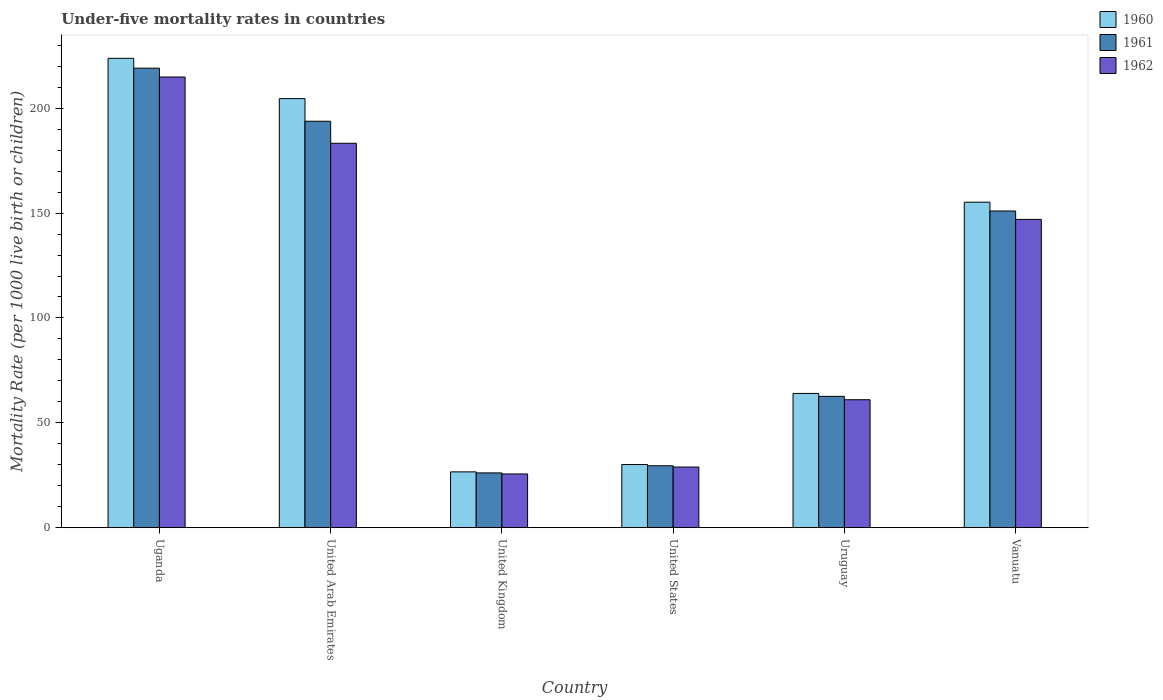How many different coloured bars are there?
Offer a very short reply. 3. How many groups of bars are there?
Your answer should be very brief. 6. Are the number of bars per tick equal to the number of legend labels?
Offer a very short reply. Yes. What is the label of the 6th group of bars from the left?
Provide a succinct answer. Vanuatu. In how many cases, is the number of bars for a given country not equal to the number of legend labels?
Provide a succinct answer. 0. What is the under-five mortality rate in 1962 in Uganda?
Keep it short and to the point. 214.9. Across all countries, what is the maximum under-five mortality rate in 1962?
Your answer should be very brief. 214.9. Across all countries, what is the minimum under-five mortality rate in 1961?
Keep it short and to the point. 26.1. In which country was the under-five mortality rate in 1960 maximum?
Your answer should be very brief. Uganda. What is the total under-five mortality rate in 1961 in the graph?
Provide a short and direct response. 682.1. What is the difference between the under-five mortality rate in 1962 in Uganda and that in United States?
Give a very brief answer. 186. What is the average under-five mortality rate in 1960 per country?
Offer a terse response. 117.38. What is the difference between the under-five mortality rate of/in 1960 and under-five mortality rate of/in 1961 in Uruguay?
Your response must be concise. 1.4. What is the ratio of the under-five mortality rate in 1962 in United Arab Emirates to that in Vanuatu?
Your response must be concise. 1.25. Is the under-five mortality rate in 1960 in United Kingdom less than that in Uruguay?
Provide a short and direct response. Yes. Is the difference between the under-five mortality rate in 1960 in United Arab Emirates and United States greater than the difference between the under-five mortality rate in 1961 in United Arab Emirates and United States?
Ensure brevity in your answer.  Yes. What is the difference between the highest and the second highest under-five mortality rate in 1960?
Offer a terse response. -49.4. What is the difference between the highest and the lowest under-five mortality rate in 1962?
Give a very brief answer. 189.3. What does the 2nd bar from the right in Uruguay represents?
Keep it short and to the point. 1961. Is it the case that in every country, the sum of the under-five mortality rate in 1962 and under-five mortality rate in 1960 is greater than the under-five mortality rate in 1961?
Your answer should be compact. Yes. How many countries are there in the graph?
Provide a succinct answer. 6. Does the graph contain any zero values?
Ensure brevity in your answer.  No. What is the title of the graph?
Offer a terse response. Under-five mortality rates in countries. What is the label or title of the Y-axis?
Offer a very short reply. Mortality Rate (per 1000 live birth or children). What is the Mortality Rate (per 1000 live birth or children) of 1960 in Uganda?
Your answer should be compact. 223.8. What is the Mortality Rate (per 1000 live birth or children) in 1961 in Uganda?
Your response must be concise. 219.1. What is the Mortality Rate (per 1000 live birth or children) in 1962 in Uganda?
Offer a terse response. 214.9. What is the Mortality Rate (per 1000 live birth or children) in 1960 in United Arab Emirates?
Your answer should be very brief. 204.6. What is the Mortality Rate (per 1000 live birth or children) of 1961 in United Arab Emirates?
Offer a terse response. 193.8. What is the Mortality Rate (per 1000 live birth or children) in 1962 in United Arab Emirates?
Provide a succinct answer. 183.3. What is the Mortality Rate (per 1000 live birth or children) in 1960 in United Kingdom?
Your answer should be very brief. 26.6. What is the Mortality Rate (per 1000 live birth or children) in 1961 in United Kingdom?
Your response must be concise. 26.1. What is the Mortality Rate (per 1000 live birth or children) in 1962 in United Kingdom?
Your answer should be very brief. 25.6. What is the Mortality Rate (per 1000 live birth or children) in 1960 in United States?
Give a very brief answer. 30.1. What is the Mortality Rate (per 1000 live birth or children) of 1961 in United States?
Offer a terse response. 29.5. What is the Mortality Rate (per 1000 live birth or children) in 1962 in United States?
Make the answer very short. 28.9. What is the Mortality Rate (per 1000 live birth or children) of 1961 in Uruguay?
Give a very brief answer. 62.6. What is the Mortality Rate (per 1000 live birth or children) in 1962 in Uruguay?
Provide a short and direct response. 61. What is the Mortality Rate (per 1000 live birth or children) in 1960 in Vanuatu?
Give a very brief answer. 155.2. What is the Mortality Rate (per 1000 live birth or children) of 1961 in Vanuatu?
Make the answer very short. 151. What is the Mortality Rate (per 1000 live birth or children) of 1962 in Vanuatu?
Your answer should be very brief. 147. Across all countries, what is the maximum Mortality Rate (per 1000 live birth or children) of 1960?
Provide a short and direct response. 223.8. Across all countries, what is the maximum Mortality Rate (per 1000 live birth or children) of 1961?
Make the answer very short. 219.1. Across all countries, what is the maximum Mortality Rate (per 1000 live birth or children) in 1962?
Your answer should be very brief. 214.9. Across all countries, what is the minimum Mortality Rate (per 1000 live birth or children) in 1960?
Your answer should be compact. 26.6. Across all countries, what is the minimum Mortality Rate (per 1000 live birth or children) of 1961?
Your answer should be very brief. 26.1. Across all countries, what is the minimum Mortality Rate (per 1000 live birth or children) of 1962?
Offer a terse response. 25.6. What is the total Mortality Rate (per 1000 live birth or children) of 1960 in the graph?
Offer a very short reply. 704.3. What is the total Mortality Rate (per 1000 live birth or children) of 1961 in the graph?
Give a very brief answer. 682.1. What is the total Mortality Rate (per 1000 live birth or children) of 1962 in the graph?
Your response must be concise. 660.7. What is the difference between the Mortality Rate (per 1000 live birth or children) in 1961 in Uganda and that in United Arab Emirates?
Offer a very short reply. 25.3. What is the difference between the Mortality Rate (per 1000 live birth or children) in 1962 in Uganda and that in United Arab Emirates?
Offer a very short reply. 31.6. What is the difference between the Mortality Rate (per 1000 live birth or children) of 1960 in Uganda and that in United Kingdom?
Provide a short and direct response. 197.2. What is the difference between the Mortality Rate (per 1000 live birth or children) of 1961 in Uganda and that in United Kingdom?
Ensure brevity in your answer.  193. What is the difference between the Mortality Rate (per 1000 live birth or children) in 1962 in Uganda and that in United Kingdom?
Your answer should be compact. 189.3. What is the difference between the Mortality Rate (per 1000 live birth or children) of 1960 in Uganda and that in United States?
Ensure brevity in your answer.  193.7. What is the difference between the Mortality Rate (per 1000 live birth or children) of 1961 in Uganda and that in United States?
Provide a short and direct response. 189.6. What is the difference between the Mortality Rate (per 1000 live birth or children) in 1962 in Uganda and that in United States?
Offer a terse response. 186. What is the difference between the Mortality Rate (per 1000 live birth or children) in 1960 in Uganda and that in Uruguay?
Your answer should be compact. 159.8. What is the difference between the Mortality Rate (per 1000 live birth or children) of 1961 in Uganda and that in Uruguay?
Give a very brief answer. 156.5. What is the difference between the Mortality Rate (per 1000 live birth or children) in 1962 in Uganda and that in Uruguay?
Your answer should be compact. 153.9. What is the difference between the Mortality Rate (per 1000 live birth or children) of 1960 in Uganda and that in Vanuatu?
Give a very brief answer. 68.6. What is the difference between the Mortality Rate (per 1000 live birth or children) of 1961 in Uganda and that in Vanuatu?
Your answer should be very brief. 68.1. What is the difference between the Mortality Rate (per 1000 live birth or children) in 1962 in Uganda and that in Vanuatu?
Your answer should be very brief. 67.9. What is the difference between the Mortality Rate (per 1000 live birth or children) of 1960 in United Arab Emirates and that in United Kingdom?
Offer a terse response. 178. What is the difference between the Mortality Rate (per 1000 live birth or children) of 1961 in United Arab Emirates and that in United Kingdom?
Offer a terse response. 167.7. What is the difference between the Mortality Rate (per 1000 live birth or children) in 1962 in United Arab Emirates and that in United Kingdom?
Ensure brevity in your answer.  157.7. What is the difference between the Mortality Rate (per 1000 live birth or children) in 1960 in United Arab Emirates and that in United States?
Your response must be concise. 174.5. What is the difference between the Mortality Rate (per 1000 live birth or children) in 1961 in United Arab Emirates and that in United States?
Provide a succinct answer. 164.3. What is the difference between the Mortality Rate (per 1000 live birth or children) in 1962 in United Arab Emirates and that in United States?
Your response must be concise. 154.4. What is the difference between the Mortality Rate (per 1000 live birth or children) of 1960 in United Arab Emirates and that in Uruguay?
Offer a very short reply. 140.6. What is the difference between the Mortality Rate (per 1000 live birth or children) in 1961 in United Arab Emirates and that in Uruguay?
Provide a succinct answer. 131.2. What is the difference between the Mortality Rate (per 1000 live birth or children) in 1962 in United Arab Emirates and that in Uruguay?
Your answer should be compact. 122.3. What is the difference between the Mortality Rate (per 1000 live birth or children) in 1960 in United Arab Emirates and that in Vanuatu?
Provide a succinct answer. 49.4. What is the difference between the Mortality Rate (per 1000 live birth or children) in 1961 in United Arab Emirates and that in Vanuatu?
Provide a short and direct response. 42.8. What is the difference between the Mortality Rate (per 1000 live birth or children) of 1962 in United Arab Emirates and that in Vanuatu?
Provide a succinct answer. 36.3. What is the difference between the Mortality Rate (per 1000 live birth or children) of 1961 in United Kingdom and that in United States?
Your answer should be very brief. -3.4. What is the difference between the Mortality Rate (per 1000 live birth or children) in 1962 in United Kingdom and that in United States?
Offer a very short reply. -3.3. What is the difference between the Mortality Rate (per 1000 live birth or children) of 1960 in United Kingdom and that in Uruguay?
Ensure brevity in your answer.  -37.4. What is the difference between the Mortality Rate (per 1000 live birth or children) of 1961 in United Kingdom and that in Uruguay?
Your response must be concise. -36.5. What is the difference between the Mortality Rate (per 1000 live birth or children) of 1962 in United Kingdom and that in Uruguay?
Provide a succinct answer. -35.4. What is the difference between the Mortality Rate (per 1000 live birth or children) in 1960 in United Kingdom and that in Vanuatu?
Your answer should be very brief. -128.6. What is the difference between the Mortality Rate (per 1000 live birth or children) in 1961 in United Kingdom and that in Vanuatu?
Your answer should be very brief. -124.9. What is the difference between the Mortality Rate (per 1000 live birth or children) of 1962 in United Kingdom and that in Vanuatu?
Make the answer very short. -121.4. What is the difference between the Mortality Rate (per 1000 live birth or children) in 1960 in United States and that in Uruguay?
Ensure brevity in your answer.  -33.9. What is the difference between the Mortality Rate (per 1000 live birth or children) in 1961 in United States and that in Uruguay?
Provide a short and direct response. -33.1. What is the difference between the Mortality Rate (per 1000 live birth or children) in 1962 in United States and that in Uruguay?
Offer a terse response. -32.1. What is the difference between the Mortality Rate (per 1000 live birth or children) in 1960 in United States and that in Vanuatu?
Your response must be concise. -125.1. What is the difference between the Mortality Rate (per 1000 live birth or children) of 1961 in United States and that in Vanuatu?
Offer a very short reply. -121.5. What is the difference between the Mortality Rate (per 1000 live birth or children) of 1962 in United States and that in Vanuatu?
Provide a succinct answer. -118.1. What is the difference between the Mortality Rate (per 1000 live birth or children) of 1960 in Uruguay and that in Vanuatu?
Offer a terse response. -91.2. What is the difference between the Mortality Rate (per 1000 live birth or children) in 1961 in Uruguay and that in Vanuatu?
Provide a succinct answer. -88.4. What is the difference between the Mortality Rate (per 1000 live birth or children) of 1962 in Uruguay and that in Vanuatu?
Your response must be concise. -86. What is the difference between the Mortality Rate (per 1000 live birth or children) of 1960 in Uganda and the Mortality Rate (per 1000 live birth or children) of 1962 in United Arab Emirates?
Keep it short and to the point. 40.5. What is the difference between the Mortality Rate (per 1000 live birth or children) of 1961 in Uganda and the Mortality Rate (per 1000 live birth or children) of 1962 in United Arab Emirates?
Keep it short and to the point. 35.8. What is the difference between the Mortality Rate (per 1000 live birth or children) of 1960 in Uganda and the Mortality Rate (per 1000 live birth or children) of 1961 in United Kingdom?
Provide a short and direct response. 197.7. What is the difference between the Mortality Rate (per 1000 live birth or children) of 1960 in Uganda and the Mortality Rate (per 1000 live birth or children) of 1962 in United Kingdom?
Your answer should be very brief. 198.2. What is the difference between the Mortality Rate (per 1000 live birth or children) of 1961 in Uganda and the Mortality Rate (per 1000 live birth or children) of 1962 in United Kingdom?
Your answer should be compact. 193.5. What is the difference between the Mortality Rate (per 1000 live birth or children) in 1960 in Uganda and the Mortality Rate (per 1000 live birth or children) in 1961 in United States?
Provide a succinct answer. 194.3. What is the difference between the Mortality Rate (per 1000 live birth or children) in 1960 in Uganda and the Mortality Rate (per 1000 live birth or children) in 1962 in United States?
Offer a terse response. 194.9. What is the difference between the Mortality Rate (per 1000 live birth or children) in 1961 in Uganda and the Mortality Rate (per 1000 live birth or children) in 1962 in United States?
Make the answer very short. 190.2. What is the difference between the Mortality Rate (per 1000 live birth or children) of 1960 in Uganda and the Mortality Rate (per 1000 live birth or children) of 1961 in Uruguay?
Provide a succinct answer. 161.2. What is the difference between the Mortality Rate (per 1000 live birth or children) of 1960 in Uganda and the Mortality Rate (per 1000 live birth or children) of 1962 in Uruguay?
Provide a short and direct response. 162.8. What is the difference between the Mortality Rate (per 1000 live birth or children) in 1961 in Uganda and the Mortality Rate (per 1000 live birth or children) in 1962 in Uruguay?
Offer a very short reply. 158.1. What is the difference between the Mortality Rate (per 1000 live birth or children) of 1960 in Uganda and the Mortality Rate (per 1000 live birth or children) of 1961 in Vanuatu?
Keep it short and to the point. 72.8. What is the difference between the Mortality Rate (per 1000 live birth or children) in 1960 in Uganda and the Mortality Rate (per 1000 live birth or children) in 1962 in Vanuatu?
Your answer should be compact. 76.8. What is the difference between the Mortality Rate (per 1000 live birth or children) of 1961 in Uganda and the Mortality Rate (per 1000 live birth or children) of 1962 in Vanuatu?
Offer a very short reply. 72.1. What is the difference between the Mortality Rate (per 1000 live birth or children) in 1960 in United Arab Emirates and the Mortality Rate (per 1000 live birth or children) in 1961 in United Kingdom?
Your answer should be very brief. 178.5. What is the difference between the Mortality Rate (per 1000 live birth or children) in 1960 in United Arab Emirates and the Mortality Rate (per 1000 live birth or children) in 1962 in United Kingdom?
Keep it short and to the point. 179. What is the difference between the Mortality Rate (per 1000 live birth or children) of 1961 in United Arab Emirates and the Mortality Rate (per 1000 live birth or children) of 1962 in United Kingdom?
Your answer should be very brief. 168.2. What is the difference between the Mortality Rate (per 1000 live birth or children) in 1960 in United Arab Emirates and the Mortality Rate (per 1000 live birth or children) in 1961 in United States?
Offer a terse response. 175.1. What is the difference between the Mortality Rate (per 1000 live birth or children) in 1960 in United Arab Emirates and the Mortality Rate (per 1000 live birth or children) in 1962 in United States?
Keep it short and to the point. 175.7. What is the difference between the Mortality Rate (per 1000 live birth or children) of 1961 in United Arab Emirates and the Mortality Rate (per 1000 live birth or children) of 1962 in United States?
Offer a very short reply. 164.9. What is the difference between the Mortality Rate (per 1000 live birth or children) in 1960 in United Arab Emirates and the Mortality Rate (per 1000 live birth or children) in 1961 in Uruguay?
Give a very brief answer. 142. What is the difference between the Mortality Rate (per 1000 live birth or children) in 1960 in United Arab Emirates and the Mortality Rate (per 1000 live birth or children) in 1962 in Uruguay?
Make the answer very short. 143.6. What is the difference between the Mortality Rate (per 1000 live birth or children) of 1961 in United Arab Emirates and the Mortality Rate (per 1000 live birth or children) of 1962 in Uruguay?
Ensure brevity in your answer.  132.8. What is the difference between the Mortality Rate (per 1000 live birth or children) in 1960 in United Arab Emirates and the Mortality Rate (per 1000 live birth or children) in 1961 in Vanuatu?
Offer a very short reply. 53.6. What is the difference between the Mortality Rate (per 1000 live birth or children) of 1960 in United Arab Emirates and the Mortality Rate (per 1000 live birth or children) of 1962 in Vanuatu?
Your response must be concise. 57.6. What is the difference between the Mortality Rate (per 1000 live birth or children) of 1961 in United Arab Emirates and the Mortality Rate (per 1000 live birth or children) of 1962 in Vanuatu?
Your answer should be compact. 46.8. What is the difference between the Mortality Rate (per 1000 live birth or children) in 1960 in United Kingdom and the Mortality Rate (per 1000 live birth or children) in 1961 in United States?
Provide a short and direct response. -2.9. What is the difference between the Mortality Rate (per 1000 live birth or children) of 1961 in United Kingdom and the Mortality Rate (per 1000 live birth or children) of 1962 in United States?
Give a very brief answer. -2.8. What is the difference between the Mortality Rate (per 1000 live birth or children) in 1960 in United Kingdom and the Mortality Rate (per 1000 live birth or children) in 1961 in Uruguay?
Give a very brief answer. -36. What is the difference between the Mortality Rate (per 1000 live birth or children) in 1960 in United Kingdom and the Mortality Rate (per 1000 live birth or children) in 1962 in Uruguay?
Offer a very short reply. -34.4. What is the difference between the Mortality Rate (per 1000 live birth or children) of 1961 in United Kingdom and the Mortality Rate (per 1000 live birth or children) of 1962 in Uruguay?
Provide a succinct answer. -34.9. What is the difference between the Mortality Rate (per 1000 live birth or children) in 1960 in United Kingdom and the Mortality Rate (per 1000 live birth or children) in 1961 in Vanuatu?
Offer a terse response. -124.4. What is the difference between the Mortality Rate (per 1000 live birth or children) in 1960 in United Kingdom and the Mortality Rate (per 1000 live birth or children) in 1962 in Vanuatu?
Keep it short and to the point. -120.4. What is the difference between the Mortality Rate (per 1000 live birth or children) of 1961 in United Kingdom and the Mortality Rate (per 1000 live birth or children) of 1962 in Vanuatu?
Your answer should be very brief. -120.9. What is the difference between the Mortality Rate (per 1000 live birth or children) in 1960 in United States and the Mortality Rate (per 1000 live birth or children) in 1961 in Uruguay?
Offer a terse response. -32.5. What is the difference between the Mortality Rate (per 1000 live birth or children) in 1960 in United States and the Mortality Rate (per 1000 live birth or children) in 1962 in Uruguay?
Provide a succinct answer. -30.9. What is the difference between the Mortality Rate (per 1000 live birth or children) in 1961 in United States and the Mortality Rate (per 1000 live birth or children) in 1962 in Uruguay?
Your answer should be very brief. -31.5. What is the difference between the Mortality Rate (per 1000 live birth or children) of 1960 in United States and the Mortality Rate (per 1000 live birth or children) of 1961 in Vanuatu?
Make the answer very short. -120.9. What is the difference between the Mortality Rate (per 1000 live birth or children) of 1960 in United States and the Mortality Rate (per 1000 live birth or children) of 1962 in Vanuatu?
Give a very brief answer. -116.9. What is the difference between the Mortality Rate (per 1000 live birth or children) of 1961 in United States and the Mortality Rate (per 1000 live birth or children) of 1962 in Vanuatu?
Make the answer very short. -117.5. What is the difference between the Mortality Rate (per 1000 live birth or children) in 1960 in Uruguay and the Mortality Rate (per 1000 live birth or children) in 1961 in Vanuatu?
Your response must be concise. -87. What is the difference between the Mortality Rate (per 1000 live birth or children) in 1960 in Uruguay and the Mortality Rate (per 1000 live birth or children) in 1962 in Vanuatu?
Your answer should be very brief. -83. What is the difference between the Mortality Rate (per 1000 live birth or children) in 1961 in Uruguay and the Mortality Rate (per 1000 live birth or children) in 1962 in Vanuatu?
Give a very brief answer. -84.4. What is the average Mortality Rate (per 1000 live birth or children) of 1960 per country?
Keep it short and to the point. 117.38. What is the average Mortality Rate (per 1000 live birth or children) in 1961 per country?
Provide a succinct answer. 113.68. What is the average Mortality Rate (per 1000 live birth or children) of 1962 per country?
Offer a terse response. 110.12. What is the difference between the Mortality Rate (per 1000 live birth or children) of 1960 and Mortality Rate (per 1000 live birth or children) of 1961 in Uganda?
Offer a terse response. 4.7. What is the difference between the Mortality Rate (per 1000 live birth or children) in 1961 and Mortality Rate (per 1000 live birth or children) in 1962 in Uganda?
Your answer should be very brief. 4.2. What is the difference between the Mortality Rate (per 1000 live birth or children) of 1960 and Mortality Rate (per 1000 live birth or children) of 1961 in United Arab Emirates?
Ensure brevity in your answer.  10.8. What is the difference between the Mortality Rate (per 1000 live birth or children) of 1960 and Mortality Rate (per 1000 live birth or children) of 1962 in United Arab Emirates?
Provide a short and direct response. 21.3. What is the difference between the Mortality Rate (per 1000 live birth or children) of 1960 and Mortality Rate (per 1000 live birth or children) of 1961 in United Kingdom?
Your answer should be very brief. 0.5. What is the difference between the Mortality Rate (per 1000 live birth or children) of 1960 and Mortality Rate (per 1000 live birth or children) of 1962 in United Kingdom?
Ensure brevity in your answer.  1. What is the difference between the Mortality Rate (per 1000 live birth or children) in 1961 and Mortality Rate (per 1000 live birth or children) in 1962 in United States?
Give a very brief answer. 0.6. What is the difference between the Mortality Rate (per 1000 live birth or children) of 1960 and Mortality Rate (per 1000 live birth or children) of 1961 in Uruguay?
Offer a terse response. 1.4. What is the difference between the Mortality Rate (per 1000 live birth or children) of 1960 and Mortality Rate (per 1000 live birth or children) of 1961 in Vanuatu?
Offer a very short reply. 4.2. What is the difference between the Mortality Rate (per 1000 live birth or children) of 1961 and Mortality Rate (per 1000 live birth or children) of 1962 in Vanuatu?
Offer a very short reply. 4. What is the ratio of the Mortality Rate (per 1000 live birth or children) of 1960 in Uganda to that in United Arab Emirates?
Offer a terse response. 1.09. What is the ratio of the Mortality Rate (per 1000 live birth or children) of 1961 in Uganda to that in United Arab Emirates?
Your answer should be compact. 1.13. What is the ratio of the Mortality Rate (per 1000 live birth or children) of 1962 in Uganda to that in United Arab Emirates?
Your answer should be very brief. 1.17. What is the ratio of the Mortality Rate (per 1000 live birth or children) in 1960 in Uganda to that in United Kingdom?
Your response must be concise. 8.41. What is the ratio of the Mortality Rate (per 1000 live birth or children) of 1961 in Uganda to that in United Kingdom?
Your answer should be compact. 8.39. What is the ratio of the Mortality Rate (per 1000 live birth or children) of 1962 in Uganda to that in United Kingdom?
Provide a short and direct response. 8.39. What is the ratio of the Mortality Rate (per 1000 live birth or children) in 1960 in Uganda to that in United States?
Provide a short and direct response. 7.44. What is the ratio of the Mortality Rate (per 1000 live birth or children) of 1961 in Uganda to that in United States?
Give a very brief answer. 7.43. What is the ratio of the Mortality Rate (per 1000 live birth or children) of 1962 in Uganda to that in United States?
Give a very brief answer. 7.44. What is the ratio of the Mortality Rate (per 1000 live birth or children) of 1960 in Uganda to that in Uruguay?
Give a very brief answer. 3.5. What is the ratio of the Mortality Rate (per 1000 live birth or children) in 1961 in Uganda to that in Uruguay?
Your answer should be very brief. 3.5. What is the ratio of the Mortality Rate (per 1000 live birth or children) of 1962 in Uganda to that in Uruguay?
Keep it short and to the point. 3.52. What is the ratio of the Mortality Rate (per 1000 live birth or children) of 1960 in Uganda to that in Vanuatu?
Offer a terse response. 1.44. What is the ratio of the Mortality Rate (per 1000 live birth or children) in 1961 in Uganda to that in Vanuatu?
Keep it short and to the point. 1.45. What is the ratio of the Mortality Rate (per 1000 live birth or children) in 1962 in Uganda to that in Vanuatu?
Your answer should be very brief. 1.46. What is the ratio of the Mortality Rate (per 1000 live birth or children) of 1960 in United Arab Emirates to that in United Kingdom?
Make the answer very short. 7.69. What is the ratio of the Mortality Rate (per 1000 live birth or children) in 1961 in United Arab Emirates to that in United Kingdom?
Keep it short and to the point. 7.43. What is the ratio of the Mortality Rate (per 1000 live birth or children) of 1962 in United Arab Emirates to that in United Kingdom?
Keep it short and to the point. 7.16. What is the ratio of the Mortality Rate (per 1000 live birth or children) in 1960 in United Arab Emirates to that in United States?
Your response must be concise. 6.8. What is the ratio of the Mortality Rate (per 1000 live birth or children) of 1961 in United Arab Emirates to that in United States?
Your answer should be very brief. 6.57. What is the ratio of the Mortality Rate (per 1000 live birth or children) in 1962 in United Arab Emirates to that in United States?
Keep it short and to the point. 6.34. What is the ratio of the Mortality Rate (per 1000 live birth or children) of 1960 in United Arab Emirates to that in Uruguay?
Your response must be concise. 3.2. What is the ratio of the Mortality Rate (per 1000 live birth or children) of 1961 in United Arab Emirates to that in Uruguay?
Provide a short and direct response. 3.1. What is the ratio of the Mortality Rate (per 1000 live birth or children) of 1962 in United Arab Emirates to that in Uruguay?
Ensure brevity in your answer.  3. What is the ratio of the Mortality Rate (per 1000 live birth or children) of 1960 in United Arab Emirates to that in Vanuatu?
Give a very brief answer. 1.32. What is the ratio of the Mortality Rate (per 1000 live birth or children) of 1961 in United Arab Emirates to that in Vanuatu?
Ensure brevity in your answer.  1.28. What is the ratio of the Mortality Rate (per 1000 live birth or children) of 1962 in United Arab Emirates to that in Vanuatu?
Ensure brevity in your answer.  1.25. What is the ratio of the Mortality Rate (per 1000 live birth or children) of 1960 in United Kingdom to that in United States?
Provide a short and direct response. 0.88. What is the ratio of the Mortality Rate (per 1000 live birth or children) in 1961 in United Kingdom to that in United States?
Your response must be concise. 0.88. What is the ratio of the Mortality Rate (per 1000 live birth or children) in 1962 in United Kingdom to that in United States?
Make the answer very short. 0.89. What is the ratio of the Mortality Rate (per 1000 live birth or children) in 1960 in United Kingdom to that in Uruguay?
Provide a short and direct response. 0.42. What is the ratio of the Mortality Rate (per 1000 live birth or children) of 1961 in United Kingdom to that in Uruguay?
Make the answer very short. 0.42. What is the ratio of the Mortality Rate (per 1000 live birth or children) in 1962 in United Kingdom to that in Uruguay?
Give a very brief answer. 0.42. What is the ratio of the Mortality Rate (per 1000 live birth or children) in 1960 in United Kingdom to that in Vanuatu?
Your answer should be very brief. 0.17. What is the ratio of the Mortality Rate (per 1000 live birth or children) of 1961 in United Kingdom to that in Vanuatu?
Give a very brief answer. 0.17. What is the ratio of the Mortality Rate (per 1000 live birth or children) of 1962 in United Kingdom to that in Vanuatu?
Offer a terse response. 0.17. What is the ratio of the Mortality Rate (per 1000 live birth or children) of 1960 in United States to that in Uruguay?
Make the answer very short. 0.47. What is the ratio of the Mortality Rate (per 1000 live birth or children) of 1961 in United States to that in Uruguay?
Your answer should be very brief. 0.47. What is the ratio of the Mortality Rate (per 1000 live birth or children) of 1962 in United States to that in Uruguay?
Offer a very short reply. 0.47. What is the ratio of the Mortality Rate (per 1000 live birth or children) in 1960 in United States to that in Vanuatu?
Keep it short and to the point. 0.19. What is the ratio of the Mortality Rate (per 1000 live birth or children) of 1961 in United States to that in Vanuatu?
Your answer should be compact. 0.2. What is the ratio of the Mortality Rate (per 1000 live birth or children) of 1962 in United States to that in Vanuatu?
Provide a short and direct response. 0.2. What is the ratio of the Mortality Rate (per 1000 live birth or children) of 1960 in Uruguay to that in Vanuatu?
Make the answer very short. 0.41. What is the ratio of the Mortality Rate (per 1000 live birth or children) of 1961 in Uruguay to that in Vanuatu?
Your answer should be compact. 0.41. What is the ratio of the Mortality Rate (per 1000 live birth or children) in 1962 in Uruguay to that in Vanuatu?
Your response must be concise. 0.41. What is the difference between the highest and the second highest Mortality Rate (per 1000 live birth or children) in 1961?
Your response must be concise. 25.3. What is the difference between the highest and the second highest Mortality Rate (per 1000 live birth or children) in 1962?
Give a very brief answer. 31.6. What is the difference between the highest and the lowest Mortality Rate (per 1000 live birth or children) in 1960?
Make the answer very short. 197.2. What is the difference between the highest and the lowest Mortality Rate (per 1000 live birth or children) in 1961?
Give a very brief answer. 193. What is the difference between the highest and the lowest Mortality Rate (per 1000 live birth or children) of 1962?
Make the answer very short. 189.3. 